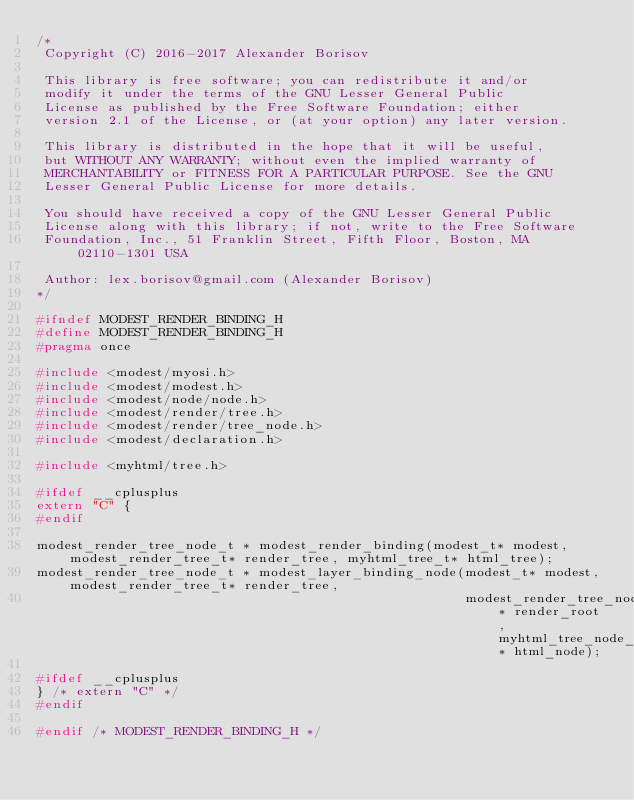Convert code to text. <code><loc_0><loc_0><loc_500><loc_500><_C_>/*
 Copyright (C) 2016-2017 Alexander Borisov
 
 This library is free software; you can redistribute it and/or
 modify it under the terms of the GNU Lesser General Public
 License as published by the Free Software Foundation; either
 version 2.1 of the License, or (at your option) any later version.
 
 This library is distributed in the hope that it will be useful,
 but WITHOUT ANY WARRANTY; without even the implied warranty of
 MERCHANTABILITY or FITNESS FOR A PARTICULAR PURPOSE. See the GNU
 Lesser General Public License for more details.
 
 You should have received a copy of the GNU Lesser General Public
 License along with this library; if not, write to the Free Software
 Foundation, Inc., 51 Franklin Street, Fifth Floor, Boston, MA 02110-1301 USA
 
 Author: lex.borisov@gmail.com (Alexander Borisov)
*/

#ifndef MODEST_RENDER_BINDING_H
#define MODEST_RENDER_BINDING_H
#pragma once

#include <modest/myosi.h>
#include <modest/modest.h>
#include <modest/node/node.h>
#include <modest/render/tree.h>
#include <modest/render/tree_node.h>
#include <modest/declaration.h>

#include <myhtml/tree.h>

#ifdef __cplusplus
extern "C" {
#endif

modest_render_tree_node_t * modest_render_binding(modest_t* modest, modest_render_tree_t* render_tree, myhtml_tree_t* html_tree);
modest_render_tree_node_t * modest_layer_binding_node(modest_t* modest, modest_render_tree_t* render_tree,
                                                      modest_render_tree_node_t* render_root, myhtml_tree_node_t* html_node);
    
#ifdef __cplusplus
} /* extern "C" */
#endif

#endif /* MODEST_RENDER_BINDING_H */
</code> 